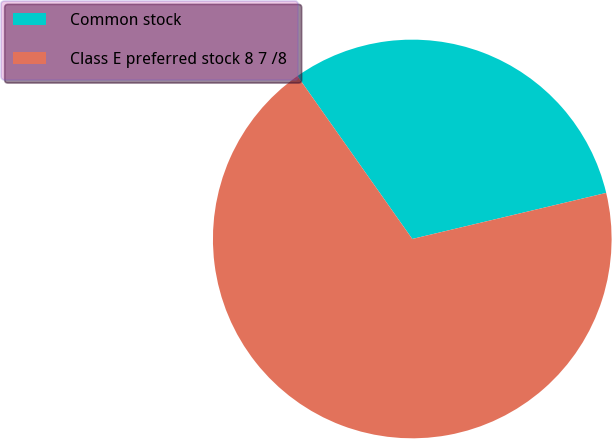<chart> <loc_0><loc_0><loc_500><loc_500><pie_chart><fcel>Common stock<fcel>Class E preferred stock 8 7 /8<nl><fcel>31.06%<fcel>68.94%<nl></chart> 